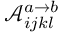<formula> <loc_0><loc_0><loc_500><loc_500>\ m a t h s c r { A } _ { i j k l } ^ { a \rightarrow b }</formula> 